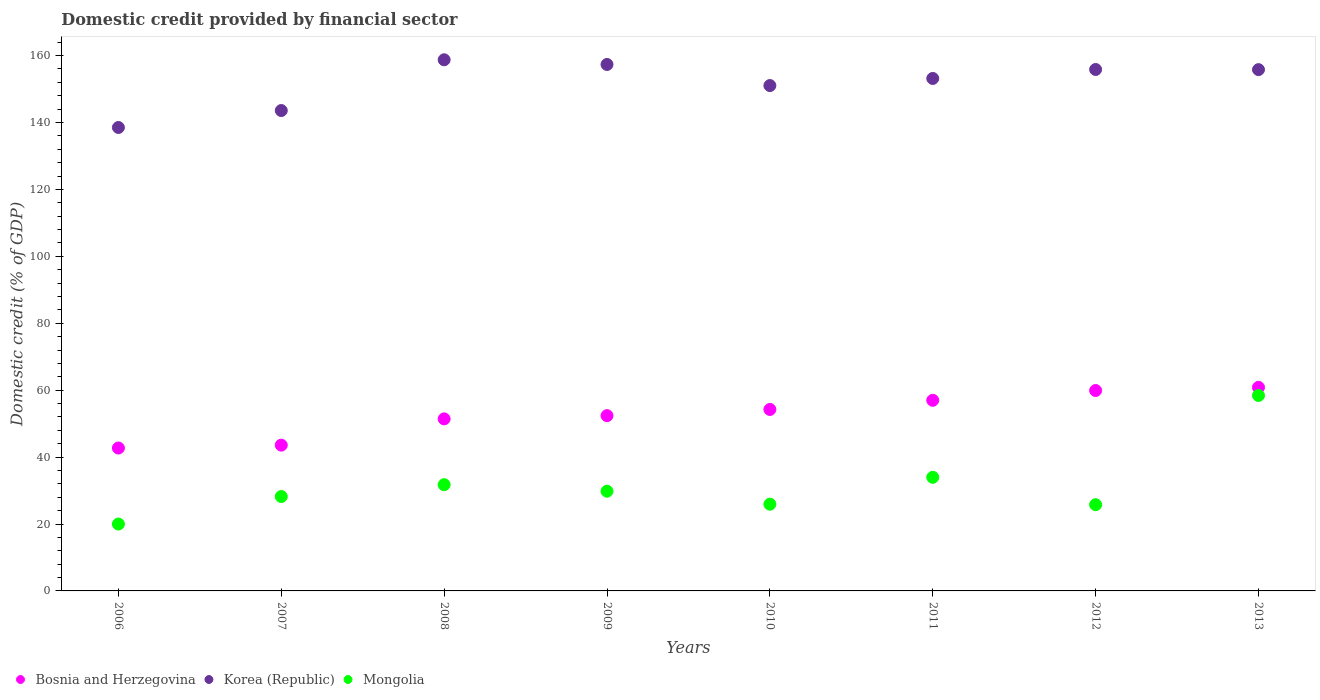How many different coloured dotlines are there?
Your response must be concise. 3. What is the domestic credit in Mongolia in 2009?
Ensure brevity in your answer.  29.8. Across all years, what is the maximum domestic credit in Bosnia and Herzegovina?
Your answer should be compact. 60.84. Across all years, what is the minimum domestic credit in Korea (Republic)?
Provide a short and direct response. 138.51. In which year was the domestic credit in Mongolia maximum?
Offer a very short reply. 2013. In which year was the domestic credit in Bosnia and Herzegovina minimum?
Your answer should be very brief. 2006. What is the total domestic credit in Mongolia in the graph?
Your answer should be compact. 253.83. What is the difference between the domestic credit in Korea (Republic) in 2007 and that in 2008?
Keep it short and to the point. -15.17. What is the difference between the domestic credit in Mongolia in 2008 and the domestic credit in Korea (Republic) in 2009?
Ensure brevity in your answer.  -125.6. What is the average domestic credit in Mongolia per year?
Provide a succinct answer. 31.73. In the year 2012, what is the difference between the domestic credit in Mongolia and domestic credit in Korea (Republic)?
Provide a succinct answer. -130.07. What is the ratio of the domestic credit in Mongolia in 2011 to that in 2012?
Provide a succinct answer. 1.32. Is the domestic credit in Bosnia and Herzegovina in 2010 less than that in 2011?
Provide a short and direct response. Yes. Is the difference between the domestic credit in Mongolia in 2010 and 2013 greater than the difference between the domestic credit in Korea (Republic) in 2010 and 2013?
Provide a succinct answer. No. What is the difference between the highest and the second highest domestic credit in Bosnia and Herzegovina?
Your response must be concise. 0.94. What is the difference between the highest and the lowest domestic credit in Bosnia and Herzegovina?
Ensure brevity in your answer.  18.13. Is the sum of the domestic credit in Bosnia and Herzegovina in 2007 and 2009 greater than the maximum domestic credit in Mongolia across all years?
Offer a very short reply. Yes. Does the domestic credit in Mongolia monotonically increase over the years?
Your answer should be compact. No. Is the domestic credit in Mongolia strictly less than the domestic credit in Bosnia and Herzegovina over the years?
Offer a terse response. Yes. How many years are there in the graph?
Provide a succinct answer. 8. Where does the legend appear in the graph?
Your response must be concise. Bottom left. How many legend labels are there?
Your answer should be very brief. 3. How are the legend labels stacked?
Provide a succinct answer. Horizontal. What is the title of the graph?
Ensure brevity in your answer.  Domestic credit provided by financial sector. Does "Low income" appear as one of the legend labels in the graph?
Your answer should be compact. No. What is the label or title of the X-axis?
Your answer should be very brief. Years. What is the label or title of the Y-axis?
Your answer should be very brief. Domestic credit (% of GDP). What is the Domestic credit (% of GDP) of Bosnia and Herzegovina in 2006?
Ensure brevity in your answer.  42.71. What is the Domestic credit (% of GDP) in Korea (Republic) in 2006?
Your response must be concise. 138.51. What is the Domestic credit (% of GDP) of Mongolia in 2006?
Give a very brief answer. 19.99. What is the Domestic credit (% of GDP) in Bosnia and Herzegovina in 2007?
Your answer should be compact. 43.57. What is the Domestic credit (% of GDP) in Korea (Republic) in 2007?
Ensure brevity in your answer.  143.58. What is the Domestic credit (% of GDP) of Mongolia in 2007?
Offer a terse response. 28.21. What is the Domestic credit (% of GDP) in Bosnia and Herzegovina in 2008?
Ensure brevity in your answer.  51.42. What is the Domestic credit (% of GDP) in Korea (Republic) in 2008?
Make the answer very short. 158.75. What is the Domestic credit (% of GDP) of Mongolia in 2008?
Ensure brevity in your answer.  31.76. What is the Domestic credit (% of GDP) in Bosnia and Herzegovina in 2009?
Provide a short and direct response. 52.39. What is the Domestic credit (% of GDP) in Korea (Republic) in 2009?
Ensure brevity in your answer.  157.35. What is the Domestic credit (% of GDP) in Mongolia in 2009?
Your answer should be compact. 29.8. What is the Domestic credit (% of GDP) in Bosnia and Herzegovina in 2010?
Provide a short and direct response. 54.24. What is the Domestic credit (% of GDP) in Korea (Republic) in 2010?
Make the answer very short. 151.04. What is the Domestic credit (% of GDP) of Mongolia in 2010?
Keep it short and to the point. 25.92. What is the Domestic credit (% of GDP) in Bosnia and Herzegovina in 2011?
Give a very brief answer. 56.97. What is the Domestic credit (% of GDP) in Korea (Republic) in 2011?
Offer a terse response. 153.17. What is the Domestic credit (% of GDP) of Mongolia in 2011?
Make the answer very short. 33.96. What is the Domestic credit (% of GDP) in Bosnia and Herzegovina in 2012?
Make the answer very short. 59.9. What is the Domestic credit (% of GDP) in Korea (Republic) in 2012?
Your answer should be very brief. 155.85. What is the Domestic credit (% of GDP) in Mongolia in 2012?
Ensure brevity in your answer.  25.77. What is the Domestic credit (% of GDP) of Bosnia and Herzegovina in 2013?
Provide a short and direct response. 60.84. What is the Domestic credit (% of GDP) of Korea (Republic) in 2013?
Provide a short and direct response. 155.8. What is the Domestic credit (% of GDP) in Mongolia in 2013?
Give a very brief answer. 58.41. Across all years, what is the maximum Domestic credit (% of GDP) of Bosnia and Herzegovina?
Give a very brief answer. 60.84. Across all years, what is the maximum Domestic credit (% of GDP) in Korea (Republic)?
Your answer should be very brief. 158.75. Across all years, what is the maximum Domestic credit (% of GDP) of Mongolia?
Keep it short and to the point. 58.41. Across all years, what is the minimum Domestic credit (% of GDP) in Bosnia and Herzegovina?
Your answer should be very brief. 42.71. Across all years, what is the minimum Domestic credit (% of GDP) in Korea (Republic)?
Keep it short and to the point. 138.51. Across all years, what is the minimum Domestic credit (% of GDP) of Mongolia?
Your answer should be very brief. 19.99. What is the total Domestic credit (% of GDP) in Bosnia and Herzegovina in the graph?
Your response must be concise. 422.05. What is the total Domestic credit (% of GDP) in Korea (Republic) in the graph?
Make the answer very short. 1214.04. What is the total Domestic credit (% of GDP) of Mongolia in the graph?
Offer a terse response. 253.83. What is the difference between the Domestic credit (% of GDP) of Bosnia and Herzegovina in 2006 and that in 2007?
Your answer should be compact. -0.86. What is the difference between the Domestic credit (% of GDP) in Korea (Republic) in 2006 and that in 2007?
Offer a terse response. -5.07. What is the difference between the Domestic credit (% of GDP) of Mongolia in 2006 and that in 2007?
Offer a terse response. -8.23. What is the difference between the Domestic credit (% of GDP) in Bosnia and Herzegovina in 2006 and that in 2008?
Provide a succinct answer. -8.71. What is the difference between the Domestic credit (% of GDP) in Korea (Republic) in 2006 and that in 2008?
Keep it short and to the point. -20.23. What is the difference between the Domestic credit (% of GDP) in Mongolia in 2006 and that in 2008?
Offer a very short reply. -11.77. What is the difference between the Domestic credit (% of GDP) of Bosnia and Herzegovina in 2006 and that in 2009?
Your response must be concise. -9.68. What is the difference between the Domestic credit (% of GDP) in Korea (Republic) in 2006 and that in 2009?
Offer a very short reply. -18.84. What is the difference between the Domestic credit (% of GDP) in Mongolia in 2006 and that in 2009?
Provide a succinct answer. -9.82. What is the difference between the Domestic credit (% of GDP) in Bosnia and Herzegovina in 2006 and that in 2010?
Provide a succinct answer. -11.53. What is the difference between the Domestic credit (% of GDP) of Korea (Republic) in 2006 and that in 2010?
Give a very brief answer. -12.53. What is the difference between the Domestic credit (% of GDP) of Mongolia in 2006 and that in 2010?
Your answer should be compact. -5.93. What is the difference between the Domestic credit (% of GDP) in Bosnia and Herzegovina in 2006 and that in 2011?
Offer a very short reply. -14.26. What is the difference between the Domestic credit (% of GDP) in Korea (Republic) in 2006 and that in 2011?
Make the answer very short. -14.65. What is the difference between the Domestic credit (% of GDP) of Mongolia in 2006 and that in 2011?
Your answer should be compact. -13.97. What is the difference between the Domestic credit (% of GDP) in Bosnia and Herzegovina in 2006 and that in 2012?
Offer a terse response. -17.19. What is the difference between the Domestic credit (% of GDP) in Korea (Republic) in 2006 and that in 2012?
Provide a short and direct response. -17.33. What is the difference between the Domestic credit (% of GDP) of Mongolia in 2006 and that in 2012?
Keep it short and to the point. -5.79. What is the difference between the Domestic credit (% of GDP) of Bosnia and Herzegovina in 2006 and that in 2013?
Provide a succinct answer. -18.13. What is the difference between the Domestic credit (% of GDP) in Korea (Republic) in 2006 and that in 2013?
Provide a short and direct response. -17.29. What is the difference between the Domestic credit (% of GDP) of Mongolia in 2006 and that in 2013?
Make the answer very short. -38.42. What is the difference between the Domestic credit (% of GDP) of Bosnia and Herzegovina in 2007 and that in 2008?
Provide a short and direct response. -7.85. What is the difference between the Domestic credit (% of GDP) in Korea (Republic) in 2007 and that in 2008?
Make the answer very short. -15.17. What is the difference between the Domestic credit (% of GDP) in Mongolia in 2007 and that in 2008?
Give a very brief answer. -3.54. What is the difference between the Domestic credit (% of GDP) of Bosnia and Herzegovina in 2007 and that in 2009?
Offer a terse response. -8.82. What is the difference between the Domestic credit (% of GDP) in Korea (Republic) in 2007 and that in 2009?
Offer a very short reply. -13.77. What is the difference between the Domestic credit (% of GDP) in Mongolia in 2007 and that in 2009?
Your answer should be compact. -1.59. What is the difference between the Domestic credit (% of GDP) of Bosnia and Herzegovina in 2007 and that in 2010?
Make the answer very short. -10.67. What is the difference between the Domestic credit (% of GDP) in Korea (Republic) in 2007 and that in 2010?
Offer a terse response. -7.46. What is the difference between the Domestic credit (% of GDP) of Mongolia in 2007 and that in 2010?
Provide a succinct answer. 2.29. What is the difference between the Domestic credit (% of GDP) in Bosnia and Herzegovina in 2007 and that in 2011?
Your response must be concise. -13.4. What is the difference between the Domestic credit (% of GDP) of Korea (Republic) in 2007 and that in 2011?
Your response must be concise. -9.59. What is the difference between the Domestic credit (% of GDP) of Mongolia in 2007 and that in 2011?
Your answer should be very brief. -5.75. What is the difference between the Domestic credit (% of GDP) in Bosnia and Herzegovina in 2007 and that in 2012?
Keep it short and to the point. -16.33. What is the difference between the Domestic credit (% of GDP) of Korea (Republic) in 2007 and that in 2012?
Keep it short and to the point. -12.27. What is the difference between the Domestic credit (% of GDP) of Mongolia in 2007 and that in 2012?
Provide a succinct answer. 2.44. What is the difference between the Domestic credit (% of GDP) of Bosnia and Herzegovina in 2007 and that in 2013?
Keep it short and to the point. -17.27. What is the difference between the Domestic credit (% of GDP) in Korea (Republic) in 2007 and that in 2013?
Offer a terse response. -12.22. What is the difference between the Domestic credit (% of GDP) in Mongolia in 2007 and that in 2013?
Offer a very short reply. -30.2. What is the difference between the Domestic credit (% of GDP) of Bosnia and Herzegovina in 2008 and that in 2009?
Your response must be concise. -0.97. What is the difference between the Domestic credit (% of GDP) in Korea (Republic) in 2008 and that in 2009?
Provide a succinct answer. 1.39. What is the difference between the Domestic credit (% of GDP) in Mongolia in 2008 and that in 2009?
Give a very brief answer. 1.95. What is the difference between the Domestic credit (% of GDP) of Bosnia and Herzegovina in 2008 and that in 2010?
Your response must be concise. -2.81. What is the difference between the Domestic credit (% of GDP) in Korea (Republic) in 2008 and that in 2010?
Your response must be concise. 7.7. What is the difference between the Domestic credit (% of GDP) of Mongolia in 2008 and that in 2010?
Offer a terse response. 5.83. What is the difference between the Domestic credit (% of GDP) of Bosnia and Herzegovina in 2008 and that in 2011?
Provide a short and direct response. -5.55. What is the difference between the Domestic credit (% of GDP) in Korea (Republic) in 2008 and that in 2011?
Your answer should be compact. 5.58. What is the difference between the Domestic credit (% of GDP) in Mongolia in 2008 and that in 2011?
Ensure brevity in your answer.  -2.2. What is the difference between the Domestic credit (% of GDP) in Bosnia and Herzegovina in 2008 and that in 2012?
Your answer should be compact. -8.48. What is the difference between the Domestic credit (% of GDP) of Korea (Republic) in 2008 and that in 2012?
Your response must be concise. 2.9. What is the difference between the Domestic credit (% of GDP) of Mongolia in 2008 and that in 2012?
Provide a succinct answer. 5.98. What is the difference between the Domestic credit (% of GDP) of Bosnia and Herzegovina in 2008 and that in 2013?
Provide a succinct answer. -9.42. What is the difference between the Domestic credit (% of GDP) of Korea (Republic) in 2008 and that in 2013?
Ensure brevity in your answer.  2.94. What is the difference between the Domestic credit (% of GDP) in Mongolia in 2008 and that in 2013?
Your answer should be very brief. -26.66. What is the difference between the Domestic credit (% of GDP) in Bosnia and Herzegovina in 2009 and that in 2010?
Provide a short and direct response. -1.85. What is the difference between the Domestic credit (% of GDP) in Korea (Republic) in 2009 and that in 2010?
Ensure brevity in your answer.  6.31. What is the difference between the Domestic credit (% of GDP) of Mongolia in 2009 and that in 2010?
Offer a very short reply. 3.88. What is the difference between the Domestic credit (% of GDP) in Bosnia and Herzegovina in 2009 and that in 2011?
Offer a very short reply. -4.58. What is the difference between the Domestic credit (% of GDP) in Korea (Republic) in 2009 and that in 2011?
Your answer should be compact. 4.19. What is the difference between the Domestic credit (% of GDP) in Mongolia in 2009 and that in 2011?
Provide a succinct answer. -4.16. What is the difference between the Domestic credit (% of GDP) in Bosnia and Herzegovina in 2009 and that in 2012?
Keep it short and to the point. -7.51. What is the difference between the Domestic credit (% of GDP) of Korea (Republic) in 2009 and that in 2012?
Make the answer very short. 1.51. What is the difference between the Domestic credit (% of GDP) in Mongolia in 2009 and that in 2012?
Your answer should be compact. 4.03. What is the difference between the Domestic credit (% of GDP) in Bosnia and Herzegovina in 2009 and that in 2013?
Your answer should be very brief. -8.45. What is the difference between the Domestic credit (% of GDP) in Korea (Republic) in 2009 and that in 2013?
Offer a very short reply. 1.55. What is the difference between the Domestic credit (% of GDP) of Mongolia in 2009 and that in 2013?
Ensure brevity in your answer.  -28.61. What is the difference between the Domestic credit (% of GDP) in Bosnia and Herzegovina in 2010 and that in 2011?
Make the answer very short. -2.74. What is the difference between the Domestic credit (% of GDP) in Korea (Republic) in 2010 and that in 2011?
Make the answer very short. -2.12. What is the difference between the Domestic credit (% of GDP) of Mongolia in 2010 and that in 2011?
Offer a very short reply. -8.04. What is the difference between the Domestic credit (% of GDP) in Bosnia and Herzegovina in 2010 and that in 2012?
Provide a succinct answer. -5.66. What is the difference between the Domestic credit (% of GDP) in Korea (Republic) in 2010 and that in 2012?
Provide a short and direct response. -4.8. What is the difference between the Domestic credit (% of GDP) of Mongolia in 2010 and that in 2012?
Ensure brevity in your answer.  0.15. What is the difference between the Domestic credit (% of GDP) of Bosnia and Herzegovina in 2010 and that in 2013?
Ensure brevity in your answer.  -6.61. What is the difference between the Domestic credit (% of GDP) in Korea (Republic) in 2010 and that in 2013?
Your answer should be compact. -4.76. What is the difference between the Domestic credit (% of GDP) in Mongolia in 2010 and that in 2013?
Provide a succinct answer. -32.49. What is the difference between the Domestic credit (% of GDP) in Bosnia and Herzegovina in 2011 and that in 2012?
Ensure brevity in your answer.  -2.93. What is the difference between the Domestic credit (% of GDP) of Korea (Republic) in 2011 and that in 2012?
Ensure brevity in your answer.  -2.68. What is the difference between the Domestic credit (% of GDP) of Mongolia in 2011 and that in 2012?
Your answer should be very brief. 8.19. What is the difference between the Domestic credit (% of GDP) in Bosnia and Herzegovina in 2011 and that in 2013?
Your answer should be compact. -3.87. What is the difference between the Domestic credit (% of GDP) of Korea (Republic) in 2011 and that in 2013?
Ensure brevity in your answer.  -2.64. What is the difference between the Domestic credit (% of GDP) of Mongolia in 2011 and that in 2013?
Provide a succinct answer. -24.45. What is the difference between the Domestic credit (% of GDP) in Bosnia and Herzegovina in 2012 and that in 2013?
Your answer should be very brief. -0.94. What is the difference between the Domestic credit (% of GDP) in Korea (Republic) in 2012 and that in 2013?
Offer a terse response. 0.04. What is the difference between the Domestic credit (% of GDP) of Mongolia in 2012 and that in 2013?
Keep it short and to the point. -32.64. What is the difference between the Domestic credit (% of GDP) of Bosnia and Herzegovina in 2006 and the Domestic credit (% of GDP) of Korea (Republic) in 2007?
Your response must be concise. -100.87. What is the difference between the Domestic credit (% of GDP) in Bosnia and Herzegovina in 2006 and the Domestic credit (% of GDP) in Mongolia in 2007?
Provide a succinct answer. 14.49. What is the difference between the Domestic credit (% of GDP) of Korea (Republic) in 2006 and the Domestic credit (% of GDP) of Mongolia in 2007?
Your response must be concise. 110.3. What is the difference between the Domestic credit (% of GDP) in Bosnia and Herzegovina in 2006 and the Domestic credit (% of GDP) in Korea (Republic) in 2008?
Provide a succinct answer. -116.04. What is the difference between the Domestic credit (% of GDP) of Bosnia and Herzegovina in 2006 and the Domestic credit (% of GDP) of Mongolia in 2008?
Give a very brief answer. 10.95. What is the difference between the Domestic credit (% of GDP) in Korea (Republic) in 2006 and the Domestic credit (% of GDP) in Mongolia in 2008?
Give a very brief answer. 106.76. What is the difference between the Domestic credit (% of GDP) of Bosnia and Herzegovina in 2006 and the Domestic credit (% of GDP) of Korea (Republic) in 2009?
Provide a short and direct response. -114.64. What is the difference between the Domestic credit (% of GDP) in Bosnia and Herzegovina in 2006 and the Domestic credit (% of GDP) in Mongolia in 2009?
Make the answer very short. 12.91. What is the difference between the Domestic credit (% of GDP) in Korea (Republic) in 2006 and the Domestic credit (% of GDP) in Mongolia in 2009?
Keep it short and to the point. 108.71. What is the difference between the Domestic credit (% of GDP) of Bosnia and Herzegovina in 2006 and the Domestic credit (% of GDP) of Korea (Republic) in 2010?
Your answer should be compact. -108.33. What is the difference between the Domestic credit (% of GDP) in Bosnia and Herzegovina in 2006 and the Domestic credit (% of GDP) in Mongolia in 2010?
Provide a succinct answer. 16.79. What is the difference between the Domestic credit (% of GDP) in Korea (Republic) in 2006 and the Domestic credit (% of GDP) in Mongolia in 2010?
Your answer should be compact. 112.59. What is the difference between the Domestic credit (% of GDP) of Bosnia and Herzegovina in 2006 and the Domestic credit (% of GDP) of Korea (Republic) in 2011?
Offer a terse response. -110.46. What is the difference between the Domestic credit (% of GDP) in Bosnia and Herzegovina in 2006 and the Domestic credit (% of GDP) in Mongolia in 2011?
Provide a succinct answer. 8.75. What is the difference between the Domestic credit (% of GDP) in Korea (Republic) in 2006 and the Domestic credit (% of GDP) in Mongolia in 2011?
Your response must be concise. 104.55. What is the difference between the Domestic credit (% of GDP) of Bosnia and Herzegovina in 2006 and the Domestic credit (% of GDP) of Korea (Republic) in 2012?
Ensure brevity in your answer.  -113.14. What is the difference between the Domestic credit (% of GDP) in Bosnia and Herzegovina in 2006 and the Domestic credit (% of GDP) in Mongolia in 2012?
Your answer should be very brief. 16.93. What is the difference between the Domestic credit (% of GDP) in Korea (Republic) in 2006 and the Domestic credit (% of GDP) in Mongolia in 2012?
Make the answer very short. 112.74. What is the difference between the Domestic credit (% of GDP) in Bosnia and Herzegovina in 2006 and the Domestic credit (% of GDP) in Korea (Republic) in 2013?
Your answer should be very brief. -113.09. What is the difference between the Domestic credit (% of GDP) in Bosnia and Herzegovina in 2006 and the Domestic credit (% of GDP) in Mongolia in 2013?
Provide a succinct answer. -15.7. What is the difference between the Domestic credit (% of GDP) of Korea (Republic) in 2006 and the Domestic credit (% of GDP) of Mongolia in 2013?
Provide a short and direct response. 80.1. What is the difference between the Domestic credit (% of GDP) in Bosnia and Herzegovina in 2007 and the Domestic credit (% of GDP) in Korea (Republic) in 2008?
Offer a terse response. -115.18. What is the difference between the Domestic credit (% of GDP) of Bosnia and Herzegovina in 2007 and the Domestic credit (% of GDP) of Mongolia in 2008?
Make the answer very short. 11.81. What is the difference between the Domestic credit (% of GDP) of Korea (Republic) in 2007 and the Domestic credit (% of GDP) of Mongolia in 2008?
Provide a succinct answer. 111.82. What is the difference between the Domestic credit (% of GDP) of Bosnia and Herzegovina in 2007 and the Domestic credit (% of GDP) of Korea (Republic) in 2009?
Provide a short and direct response. -113.78. What is the difference between the Domestic credit (% of GDP) in Bosnia and Herzegovina in 2007 and the Domestic credit (% of GDP) in Mongolia in 2009?
Your answer should be compact. 13.77. What is the difference between the Domestic credit (% of GDP) of Korea (Republic) in 2007 and the Domestic credit (% of GDP) of Mongolia in 2009?
Your response must be concise. 113.78. What is the difference between the Domestic credit (% of GDP) in Bosnia and Herzegovina in 2007 and the Domestic credit (% of GDP) in Korea (Republic) in 2010?
Give a very brief answer. -107.47. What is the difference between the Domestic credit (% of GDP) in Bosnia and Herzegovina in 2007 and the Domestic credit (% of GDP) in Mongolia in 2010?
Keep it short and to the point. 17.65. What is the difference between the Domestic credit (% of GDP) in Korea (Republic) in 2007 and the Domestic credit (% of GDP) in Mongolia in 2010?
Ensure brevity in your answer.  117.66. What is the difference between the Domestic credit (% of GDP) in Bosnia and Herzegovina in 2007 and the Domestic credit (% of GDP) in Korea (Republic) in 2011?
Your answer should be compact. -109.6. What is the difference between the Domestic credit (% of GDP) in Bosnia and Herzegovina in 2007 and the Domestic credit (% of GDP) in Mongolia in 2011?
Your answer should be compact. 9.61. What is the difference between the Domestic credit (% of GDP) of Korea (Republic) in 2007 and the Domestic credit (% of GDP) of Mongolia in 2011?
Your answer should be compact. 109.62. What is the difference between the Domestic credit (% of GDP) in Bosnia and Herzegovina in 2007 and the Domestic credit (% of GDP) in Korea (Republic) in 2012?
Offer a terse response. -112.28. What is the difference between the Domestic credit (% of GDP) in Bosnia and Herzegovina in 2007 and the Domestic credit (% of GDP) in Mongolia in 2012?
Your response must be concise. 17.8. What is the difference between the Domestic credit (% of GDP) in Korea (Republic) in 2007 and the Domestic credit (% of GDP) in Mongolia in 2012?
Provide a short and direct response. 117.8. What is the difference between the Domestic credit (% of GDP) in Bosnia and Herzegovina in 2007 and the Domestic credit (% of GDP) in Korea (Republic) in 2013?
Your answer should be very brief. -112.23. What is the difference between the Domestic credit (% of GDP) in Bosnia and Herzegovina in 2007 and the Domestic credit (% of GDP) in Mongolia in 2013?
Offer a very short reply. -14.84. What is the difference between the Domestic credit (% of GDP) in Korea (Republic) in 2007 and the Domestic credit (% of GDP) in Mongolia in 2013?
Your response must be concise. 85.17. What is the difference between the Domestic credit (% of GDP) in Bosnia and Herzegovina in 2008 and the Domestic credit (% of GDP) in Korea (Republic) in 2009?
Your response must be concise. -105.93. What is the difference between the Domestic credit (% of GDP) of Bosnia and Herzegovina in 2008 and the Domestic credit (% of GDP) of Mongolia in 2009?
Ensure brevity in your answer.  21.62. What is the difference between the Domestic credit (% of GDP) in Korea (Republic) in 2008 and the Domestic credit (% of GDP) in Mongolia in 2009?
Make the answer very short. 128.94. What is the difference between the Domestic credit (% of GDP) of Bosnia and Herzegovina in 2008 and the Domestic credit (% of GDP) of Korea (Republic) in 2010?
Provide a short and direct response. -99.62. What is the difference between the Domestic credit (% of GDP) in Bosnia and Herzegovina in 2008 and the Domestic credit (% of GDP) in Mongolia in 2010?
Your answer should be very brief. 25.5. What is the difference between the Domestic credit (% of GDP) in Korea (Republic) in 2008 and the Domestic credit (% of GDP) in Mongolia in 2010?
Your response must be concise. 132.82. What is the difference between the Domestic credit (% of GDP) of Bosnia and Herzegovina in 2008 and the Domestic credit (% of GDP) of Korea (Republic) in 2011?
Offer a terse response. -101.74. What is the difference between the Domestic credit (% of GDP) of Bosnia and Herzegovina in 2008 and the Domestic credit (% of GDP) of Mongolia in 2011?
Ensure brevity in your answer.  17.46. What is the difference between the Domestic credit (% of GDP) in Korea (Republic) in 2008 and the Domestic credit (% of GDP) in Mongolia in 2011?
Offer a terse response. 124.79. What is the difference between the Domestic credit (% of GDP) in Bosnia and Herzegovina in 2008 and the Domestic credit (% of GDP) in Korea (Republic) in 2012?
Your answer should be very brief. -104.42. What is the difference between the Domestic credit (% of GDP) in Bosnia and Herzegovina in 2008 and the Domestic credit (% of GDP) in Mongolia in 2012?
Make the answer very short. 25.65. What is the difference between the Domestic credit (% of GDP) in Korea (Republic) in 2008 and the Domestic credit (% of GDP) in Mongolia in 2012?
Keep it short and to the point. 132.97. What is the difference between the Domestic credit (% of GDP) in Bosnia and Herzegovina in 2008 and the Domestic credit (% of GDP) in Korea (Republic) in 2013?
Give a very brief answer. -104.38. What is the difference between the Domestic credit (% of GDP) in Bosnia and Herzegovina in 2008 and the Domestic credit (% of GDP) in Mongolia in 2013?
Your answer should be very brief. -6.99. What is the difference between the Domestic credit (% of GDP) in Korea (Republic) in 2008 and the Domestic credit (% of GDP) in Mongolia in 2013?
Offer a very short reply. 100.33. What is the difference between the Domestic credit (% of GDP) in Bosnia and Herzegovina in 2009 and the Domestic credit (% of GDP) in Korea (Republic) in 2010?
Ensure brevity in your answer.  -98.65. What is the difference between the Domestic credit (% of GDP) of Bosnia and Herzegovina in 2009 and the Domestic credit (% of GDP) of Mongolia in 2010?
Keep it short and to the point. 26.47. What is the difference between the Domestic credit (% of GDP) of Korea (Republic) in 2009 and the Domestic credit (% of GDP) of Mongolia in 2010?
Offer a very short reply. 131.43. What is the difference between the Domestic credit (% of GDP) of Bosnia and Herzegovina in 2009 and the Domestic credit (% of GDP) of Korea (Republic) in 2011?
Your answer should be very brief. -100.78. What is the difference between the Domestic credit (% of GDP) in Bosnia and Herzegovina in 2009 and the Domestic credit (% of GDP) in Mongolia in 2011?
Keep it short and to the point. 18.43. What is the difference between the Domestic credit (% of GDP) of Korea (Republic) in 2009 and the Domestic credit (% of GDP) of Mongolia in 2011?
Offer a terse response. 123.39. What is the difference between the Domestic credit (% of GDP) of Bosnia and Herzegovina in 2009 and the Domestic credit (% of GDP) of Korea (Republic) in 2012?
Your answer should be very brief. -103.46. What is the difference between the Domestic credit (% of GDP) in Bosnia and Herzegovina in 2009 and the Domestic credit (% of GDP) in Mongolia in 2012?
Keep it short and to the point. 26.61. What is the difference between the Domestic credit (% of GDP) of Korea (Republic) in 2009 and the Domestic credit (% of GDP) of Mongolia in 2012?
Provide a short and direct response. 131.58. What is the difference between the Domestic credit (% of GDP) in Bosnia and Herzegovina in 2009 and the Domestic credit (% of GDP) in Korea (Republic) in 2013?
Your answer should be very brief. -103.41. What is the difference between the Domestic credit (% of GDP) of Bosnia and Herzegovina in 2009 and the Domestic credit (% of GDP) of Mongolia in 2013?
Your answer should be very brief. -6.02. What is the difference between the Domestic credit (% of GDP) in Korea (Republic) in 2009 and the Domestic credit (% of GDP) in Mongolia in 2013?
Give a very brief answer. 98.94. What is the difference between the Domestic credit (% of GDP) in Bosnia and Herzegovina in 2010 and the Domestic credit (% of GDP) in Korea (Republic) in 2011?
Ensure brevity in your answer.  -98.93. What is the difference between the Domestic credit (% of GDP) of Bosnia and Herzegovina in 2010 and the Domestic credit (% of GDP) of Mongolia in 2011?
Give a very brief answer. 20.28. What is the difference between the Domestic credit (% of GDP) of Korea (Republic) in 2010 and the Domestic credit (% of GDP) of Mongolia in 2011?
Ensure brevity in your answer.  117.08. What is the difference between the Domestic credit (% of GDP) in Bosnia and Herzegovina in 2010 and the Domestic credit (% of GDP) in Korea (Republic) in 2012?
Offer a very short reply. -101.61. What is the difference between the Domestic credit (% of GDP) in Bosnia and Herzegovina in 2010 and the Domestic credit (% of GDP) in Mongolia in 2012?
Your answer should be compact. 28.46. What is the difference between the Domestic credit (% of GDP) of Korea (Republic) in 2010 and the Domestic credit (% of GDP) of Mongolia in 2012?
Give a very brief answer. 125.27. What is the difference between the Domestic credit (% of GDP) in Bosnia and Herzegovina in 2010 and the Domestic credit (% of GDP) in Korea (Republic) in 2013?
Give a very brief answer. -101.57. What is the difference between the Domestic credit (% of GDP) in Bosnia and Herzegovina in 2010 and the Domestic credit (% of GDP) in Mongolia in 2013?
Your answer should be compact. -4.18. What is the difference between the Domestic credit (% of GDP) in Korea (Republic) in 2010 and the Domestic credit (% of GDP) in Mongolia in 2013?
Your response must be concise. 92.63. What is the difference between the Domestic credit (% of GDP) of Bosnia and Herzegovina in 2011 and the Domestic credit (% of GDP) of Korea (Republic) in 2012?
Give a very brief answer. -98.87. What is the difference between the Domestic credit (% of GDP) of Bosnia and Herzegovina in 2011 and the Domestic credit (% of GDP) of Mongolia in 2012?
Ensure brevity in your answer.  31.2. What is the difference between the Domestic credit (% of GDP) of Korea (Republic) in 2011 and the Domestic credit (% of GDP) of Mongolia in 2012?
Keep it short and to the point. 127.39. What is the difference between the Domestic credit (% of GDP) of Bosnia and Herzegovina in 2011 and the Domestic credit (% of GDP) of Korea (Republic) in 2013?
Provide a short and direct response. -98.83. What is the difference between the Domestic credit (% of GDP) in Bosnia and Herzegovina in 2011 and the Domestic credit (% of GDP) in Mongolia in 2013?
Your answer should be compact. -1.44. What is the difference between the Domestic credit (% of GDP) of Korea (Republic) in 2011 and the Domestic credit (% of GDP) of Mongolia in 2013?
Keep it short and to the point. 94.75. What is the difference between the Domestic credit (% of GDP) in Bosnia and Herzegovina in 2012 and the Domestic credit (% of GDP) in Korea (Republic) in 2013?
Offer a terse response. -95.9. What is the difference between the Domestic credit (% of GDP) of Bosnia and Herzegovina in 2012 and the Domestic credit (% of GDP) of Mongolia in 2013?
Your answer should be compact. 1.49. What is the difference between the Domestic credit (% of GDP) of Korea (Republic) in 2012 and the Domestic credit (% of GDP) of Mongolia in 2013?
Ensure brevity in your answer.  97.43. What is the average Domestic credit (% of GDP) of Bosnia and Herzegovina per year?
Offer a very short reply. 52.76. What is the average Domestic credit (% of GDP) in Korea (Republic) per year?
Your answer should be very brief. 151.76. What is the average Domestic credit (% of GDP) in Mongolia per year?
Keep it short and to the point. 31.73. In the year 2006, what is the difference between the Domestic credit (% of GDP) in Bosnia and Herzegovina and Domestic credit (% of GDP) in Korea (Republic)?
Give a very brief answer. -95.8. In the year 2006, what is the difference between the Domestic credit (% of GDP) of Bosnia and Herzegovina and Domestic credit (% of GDP) of Mongolia?
Keep it short and to the point. 22.72. In the year 2006, what is the difference between the Domestic credit (% of GDP) of Korea (Republic) and Domestic credit (% of GDP) of Mongolia?
Ensure brevity in your answer.  118.52. In the year 2007, what is the difference between the Domestic credit (% of GDP) of Bosnia and Herzegovina and Domestic credit (% of GDP) of Korea (Republic)?
Make the answer very short. -100.01. In the year 2007, what is the difference between the Domestic credit (% of GDP) of Bosnia and Herzegovina and Domestic credit (% of GDP) of Mongolia?
Provide a succinct answer. 15.36. In the year 2007, what is the difference between the Domestic credit (% of GDP) of Korea (Republic) and Domestic credit (% of GDP) of Mongolia?
Offer a very short reply. 115.36. In the year 2008, what is the difference between the Domestic credit (% of GDP) in Bosnia and Herzegovina and Domestic credit (% of GDP) in Korea (Republic)?
Your answer should be very brief. -107.32. In the year 2008, what is the difference between the Domestic credit (% of GDP) in Bosnia and Herzegovina and Domestic credit (% of GDP) in Mongolia?
Your answer should be compact. 19.67. In the year 2008, what is the difference between the Domestic credit (% of GDP) in Korea (Republic) and Domestic credit (% of GDP) in Mongolia?
Offer a terse response. 126.99. In the year 2009, what is the difference between the Domestic credit (% of GDP) in Bosnia and Herzegovina and Domestic credit (% of GDP) in Korea (Republic)?
Your answer should be very brief. -104.96. In the year 2009, what is the difference between the Domestic credit (% of GDP) in Bosnia and Herzegovina and Domestic credit (% of GDP) in Mongolia?
Provide a succinct answer. 22.59. In the year 2009, what is the difference between the Domestic credit (% of GDP) in Korea (Republic) and Domestic credit (% of GDP) in Mongolia?
Make the answer very short. 127.55. In the year 2010, what is the difference between the Domestic credit (% of GDP) of Bosnia and Herzegovina and Domestic credit (% of GDP) of Korea (Republic)?
Your answer should be compact. -96.8. In the year 2010, what is the difference between the Domestic credit (% of GDP) of Bosnia and Herzegovina and Domestic credit (% of GDP) of Mongolia?
Give a very brief answer. 28.32. In the year 2010, what is the difference between the Domestic credit (% of GDP) of Korea (Republic) and Domestic credit (% of GDP) of Mongolia?
Your answer should be compact. 125.12. In the year 2011, what is the difference between the Domestic credit (% of GDP) of Bosnia and Herzegovina and Domestic credit (% of GDP) of Korea (Republic)?
Provide a succinct answer. -96.19. In the year 2011, what is the difference between the Domestic credit (% of GDP) in Bosnia and Herzegovina and Domestic credit (% of GDP) in Mongolia?
Offer a terse response. 23.01. In the year 2011, what is the difference between the Domestic credit (% of GDP) in Korea (Republic) and Domestic credit (% of GDP) in Mongolia?
Offer a very short reply. 119.21. In the year 2012, what is the difference between the Domestic credit (% of GDP) of Bosnia and Herzegovina and Domestic credit (% of GDP) of Korea (Republic)?
Offer a very short reply. -95.94. In the year 2012, what is the difference between the Domestic credit (% of GDP) in Bosnia and Herzegovina and Domestic credit (% of GDP) in Mongolia?
Provide a short and direct response. 34.13. In the year 2012, what is the difference between the Domestic credit (% of GDP) in Korea (Republic) and Domestic credit (% of GDP) in Mongolia?
Offer a very short reply. 130.07. In the year 2013, what is the difference between the Domestic credit (% of GDP) of Bosnia and Herzegovina and Domestic credit (% of GDP) of Korea (Republic)?
Provide a short and direct response. -94.96. In the year 2013, what is the difference between the Domestic credit (% of GDP) in Bosnia and Herzegovina and Domestic credit (% of GDP) in Mongolia?
Your answer should be very brief. 2.43. In the year 2013, what is the difference between the Domestic credit (% of GDP) in Korea (Republic) and Domestic credit (% of GDP) in Mongolia?
Your answer should be compact. 97.39. What is the ratio of the Domestic credit (% of GDP) in Bosnia and Herzegovina in 2006 to that in 2007?
Your answer should be compact. 0.98. What is the ratio of the Domestic credit (% of GDP) of Korea (Republic) in 2006 to that in 2007?
Keep it short and to the point. 0.96. What is the ratio of the Domestic credit (% of GDP) in Mongolia in 2006 to that in 2007?
Provide a succinct answer. 0.71. What is the ratio of the Domestic credit (% of GDP) in Bosnia and Herzegovina in 2006 to that in 2008?
Your answer should be very brief. 0.83. What is the ratio of the Domestic credit (% of GDP) in Korea (Republic) in 2006 to that in 2008?
Offer a terse response. 0.87. What is the ratio of the Domestic credit (% of GDP) in Mongolia in 2006 to that in 2008?
Your response must be concise. 0.63. What is the ratio of the Domestic credit (% of GDP) of Bosnia and Herzegovina in 2006 to that in 2009?
Offer a very short reply. 0.82. What is the ratio of the Domestic credit (% of GDP) in Korea (Republic) in 2006 to that in 2009?
Provide a succinct answer. 0.88. What is the ratio of the Domestic credit (% of GDP) in Mongolia in 2006 to that in 2009?
Offer a very short reply. 0.67. What is the ratio of the Domestic credit (% of GDP) of Bosnia and Herzegovina in 2006 to that in 2010?
Your answer should be very brief. 0.79. What is the ratio of the Domestic credit (% of GDP) in Korea (Republic) in 2006 to that in 2010?
Your answer should be compact. 0.92. What is the ratio of the Domestic credit (% of GDP) of Mongolia in 2006 to that in 2010?
Your answer should be very brief. 0.77. What is the ratio of the Domestic credit (% of GDP) of Bosnia and Herzegovina in 2006 to that in 2011?
Give a very brief answer. 0.75. What is the ratio of the Domestic credit (% of GDP) in Korea (Republic) in 2006 to that in 2011?
Your response must be concise. 0.9. What is the ratio of the Domestic credit (% of GDP) of Mongolia in 2006 to that in 2011?
Offer a very short reply. 0.59. What is the ratio of the Domestic credit (% of GDP) of Bosnia and Herzegovina in 2006 to that in 2012?
Give a very brief answer. 0.71. What is the ratio of the Domestic credit (% of GDP) in Korea (Republic) in 2006 to that in 2012?
Ensure brevity in your answer.  0.89. What is the ratio of the Domestic credit (% of GDP) of Mongolia in 2006 to that in 2012?
Provide a short and direct response. 0.78. What is the ratio of the Domestic credit (% of GDP) in Bosnia and Herzegovina in 2006 to that in 2013?
Your answer should be compact. 0.7. What is the ratio of the Domestic credit (% of GDP) of Korea (Republic) in 2006 to that in 2013?
Give a very brief answer. 0.89. What is the ratio of the Domestic credit (% of GDP) of Mongolia in 2006 to that in 2013?
Offer a terse response. 0.34. What is the ratio of the Domestic credit (% of GDP) in Bosnia and Herzegovina in 2007 to that in 2008?
Provide a short and direct response. 0.85. What is the ratio of the Domestic credit (% of GDP) of Korea (Republic) in 2007 to that in 2008?
Offer a very short reply. 0.9. What is the ratio of the Domestic credit (% of GDP) of Mongolia in 2007 to that in 2008?
Your answer should be compact. 0.89. What is the ratio of the Domestic credit (% of GDP) of Bosnia and Herzegovina in 2007 to that in 2009?
Your response must be concise. 0.83. What is the ratio of the Domestic credit (% of GDP) in Korea (Republic) in 2007 to that in 2009?
Your answer should be very brief. 0.91. What is the ratio of the Domestic credit (% of GDP) in Mongolia in 2007 to that in 2009?
Provide a short and direct response. 0.95. What is the ratio of the Domestic credit (% of GDP) in Bosnia and Herzegovina in 2007 to that in 2010?
Your response must be concise. 0.8. What is the ratio of the Domestic credit (% of GDP) in Korea (Republic) in 2007 to that in 2010?
Your answer should be very brief. 0.95. What is the ratio of the Domestic credit (% of GDP) in Mongolia in 2007 to that in 2010?
Keep it short and to the point. 1.09. What is the ratio of the Domestic credit (% of GDP) of Bosnia and Herzegovina in 2007 to that in 2011?
Your response must be concise. 0.76. What is the ratio of the Domestic credit (% of GDP) of Korea (Republic) in 2007 to that in 2011?
Give a very brief answer. 0.94. What is the ratio of the Domestic credit (% of GDP) of Mongolia in 2007 to that in 2011?
Make the answer very short. 0.83. What is the ratio of the Domestic credit (% of GDP) in Bosnia and Herzegovina in 2007 to that in 2012?
Your answer should be compact. 0.73. What is the ratio of the Domestic credit (% of GDP) in Korea (Republic) in 2007 to that in 2012?
Ensure brevity in your answer.  0.92. What is the ratio of the Domestic credit (% of GDP) of Mongolia in 2007 to that in 2012?
Your response must be concise. 1.09. What is the ratio of the Domestic credit (% of GDP) in Bosnia and Herzegovina in 2007 to that in 2013?
Offer a terse response. 0.72. What is the ratio of the Domestic credit (% of GDP) in Korea (Republic) in 2007 to that in 2013?
Your response must be concise. 0.92. What is the ratio of the Domestic credit (% of GDP) of Mongolia in 2007 to that in 2013?
Make the answer very short. 0.48. What is the ratio of the Domestic credit (% of GDP) of Bosnia and Herzegovina in 2008 to that in 2009?
Keep it short and to the point. 0.98. What is the ratio of the Domestic credit (% of GDP) in Korea (Republic) in 2008 to that in 2009?
Provide a succinct answer. 1.01. What is the ratio of the Domestic credit (% of GDP) of Mongolia in 2008 to that in 2009?
Provide a short and direct response. 1.07. What is the ratio of the Domestic credit (% of GDP) of Bosnia and Herzegovina in 2008 to that in 2010?
Provide a succinct answer. 0.95. What is the ratio of the Domestic credit (% of GDP) of Korea (Republic) in 2008 to that in 2010?
Your answer should be compact. 1.05. What is the ratio of the Domestic credit (% of GDP) of Mongolia in 2008 to that in 2010?
Offer a very short reply. 1.23. What is the ratio of the Domestic credit (% of GDP) of Bosnia and Herzegovina in 2008 to that in 2011?
Provide a succinct answer. 0.9. What is the ratio of the Domestic credit (% of GDP) in Korea (Republic) in 2008 to that in 2011?
Keep it short and to the point. 1.04. What is the ratio of the Domestic credit (% of GDP) in Mongolia in 2008 to that in 2011?
Make the answer very short. 0.94. What is the ratio of the Domestic credit (% of GDP) of Bosnia and Herzegovina in 2008 to that in 2012?
Provide a short and direct response. 0.86. What is the ratio of the Domestic credit (% of GDP) in Korea (Republic) in 2008 to that in 2012?
Offer a terse response. 1.02. What is the ratio of the Domestic credit (% of GDP) of Mongolia in 2008 to that in 2012?
Your answer should be compact. 1.23. What is the ratio of the Domestic credit (% of GDP) of Bosnia and Herzegovina in 2008 to that in 2013?
Offer a very short reply. 0.85. What is the ratio of the Domestic credit (% of GDP) in Korea (Republic) in 2008 to that in 2013?
Ensure brevity in your answer.  1.02. What is the ratio of the Domestic credit (% of GDP) of Mongolia in 2008 to that in 2013?
Your answer should be compact. 0.54. What is the ratio of the Domestic credit (% of GDP) of Bosnia and Herzegovina in 2009 to that in 2010?
Your answer should be compact. 0.97. What is the ratio of the Domestic credit (% of GDP) of Korea (Republic) in 2009 to that in 2010?
Your response must be concise. 1.04. What is the ratio of the Domestic credit (% of GDP) of Mongolia in 2009 to that in 2010?
Offer a very short reply. 1.15. What is the ratio of the Domestic credit (% of GDP) in Bosnia and Herzegovina in 2009 to that in 2011?
Offer a terse response. 0.92. What is the ratio of the Domestic credit (% of GDP) in Korea (Republic) in 2009 to that in 2011?
Provide a succinct answer. 1.03. What is the ratio of the Domestic credit (% of GDP) of Mongolia in 2009 to that in 2011?
Give a very brief answer. 0.88. What is the ratio of the Domestic credit (% of GDP) in Bosnia and Herzegovina in 2009 to that in 2012?
Offer a very short reply. 0.87. What is the ratio of the Domestic credit (% of GDP) of Korea (Republic) in 2009 to that in 2012?
Give a very brief answer. 1.01. What is the ratio of the Domestic credit (% of GDP) in Mongolia in 2009 to that in 2012?
Your answer should be compact. 1.16. What is the ratio of the Domestic credit (% of GDP) of Bosnia and Herzegovina in 2009 to that in 2013?
Provide a succinct answer. 0.86. What is the ratio of the Domestic credit (% of GDP) in Korea (Republic) in 2009 to that in 2013?
Your answer should be compact. 1.01. What is the ratio of the Domestic credit (% of GDP) in Mongolia in 2009 to that in 2013?
Ensure brevity in your answer.  0.51. What is the ratio of the Domestic credit (% of GDP) in Korea (Republic) in 2010 to that in 2011?
Your answer should be very brief. 0.99. What is the ratio of the Domestic credit (% of GDP) in Mongolia in 2010 to that in 2011?
Your answer should be very brief. 0.76. What is the ratio of the Domestic credit (% of GDP) in Bosnia and Herzegovina in 2010 to that in 2012?
Provide a short and direct response. 0.91. What is the ratio of the Domestic credit (% of GDP) of Korea (Republic) in 2010 to that in 2012?
Your answer should be very brief. 0.97. What is the ratio of the Domestic credit (% of GDP) in Bosnia and Herzegovina in 2010 to that in 2013?
Your answer should be very brief. 0.89. What is the ratio of the Domestic credit (% of GDP) of Korea (Republic) in 2010 to that in 2013?
Keep it short and to the point. 0.97. What is the ratio of the Domestic credit (% of GDP) of Mongolia in 2010 to that in 2013?
Provide a succinct answer. 0.44. What is the ratio of the Domestic credit (% of GDP) of Bosnia and Herzegovina in 2011 to that in 2012?
Your answer should be very brief. 0.95. What is the ratio of the Domestic credit (% of GDP) in Korea (Republic) in 2011 to that in 2012?
Provide a succinct answer. 0.98. What is the ratio of the Domestic credit (% of GDP) in Mongolia in 2011 to that in 2012?
Give a very brief answer. 1.32. What is the ratio of the Domestic credit (% of GDP) in Bosnia and Herzegovina in 2011 to that in 2013?
Offer a very short reply. 0.94. What is the ratio of the Domestic credit (% of GDP) of Korea (Republic) in 2011 to that in 2013?
Offer a terse response. 0.98. What is the ratio of the Domestic credit (% of GDP) in Mongolia in 2011 to that in 2013?
Make the answer very short. 0.58. What is the ratio of the Domestic credit (% of GDP) in Bosnia and Herzegovina in 2012 to that in 2013?
Keep it short and to the point. 0.98. What is the ratio of the Domestic credit (% of GDP) of Mongolia in 2012 to that in 2013?
Offer a terse response. 0.44. What is the difference between the highest and the second highest Domestic credit (% of GDP) of Bosnia and Herzegovina?
Your answer should be very brief. 0.94. What is the difference between the highest and the second highest Domestic credit (% of GDP) in Korea (Republic)?
Your response must be concise. 1.39. What is the difference between the highest and the second highest Domestic credit (% of GDP) of Mongolia?
Make the answer very short. 24.45. What is the difference between the highest and the lowest Domestic credit (% of GDP) of Bosnia and Herzegovina?
Offer a terse response. 18.13. What is the difference between the highest and the lowest Domestic credit (% of GDP) of Korea (Republic)?
Provide a short and direct response. 20.23. What is the difference between the highest and the lowest Domestic credit (% of GDP) in Mongolia?
Your response must be concise. 38.42. 